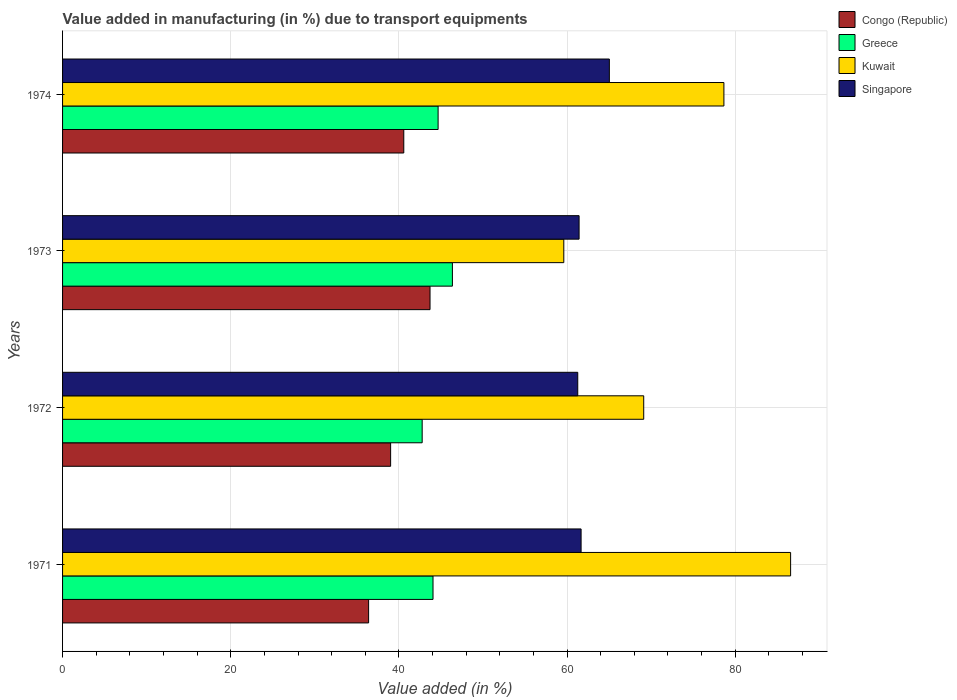How many different coloured bars are there?
Ensure brevity in your answer.  4. Are the number of bars on each tick of the Y-axis equal?
Give a very brief answer. Yes. How many bars are there on the 2nd tick from the bottom?
Keep it short and to the point. 4. What is the label of the 4th group of bars from the top?
Provide a succinct answer. 1971. In how many cases, is the number of bars for a given year not equal to the number of legend labels?
Provide a short and direct response. 0. What is the percentage of value added in manufacturing due to transport equipments in Singapore in 1971?
Your answer should be very brief. 61.67. Across all years, what is the maximum percentage of value added in manufacturing due to transport equipments in Singapore?
Offer a very short reply. 65.03. Across all years, what is the minimum percentage of value added in manufacturing due to transport equipments in Congo (Republic)?
Make the answer very short. 36.4. In which year was the percentage of value added in manufacturing due to transport equipments in Singapore maximum?
Make the answer very short. 1974. What is the total percentage of value added in manufacturing due to transport equipments in Kuwait in the graph?
Give a very brief answer. 293.97. What is the difference between the percentage of value added in manufacturing due to transport equipments in Singapore in 1971 and that in 1974?
Your answer should be very brief. -3.36. What is the difference between the percentage of value added in manufacturing due to transport equipments in Greece in 1973 and the percentage of value added in manufacturing due to transport equipments in Kuwait in 1974?
Your answer should be very brief. -32.29. What is the average percentage of value added in manufacturing due to transport equipments in Congo (Republic) per year?
Offer a terse response. 39.92. In the year 1973, what is the difference between the percentage of value added in manufacturing due to transport equipments in Greece and percentage of value added in manufacturing due to transport equipments in Congo (Republic)?
Provide a succinct answer. 2.66. What is the ratio of the percentage of value added in manufacturing due to transport equipments in Singapore in 1972 to that in 1973?
Your answer should be compact. 1. What is the difference between the highest and the second highest percentage of value added in manufacturing due to transport equipments in Singapore?
Ensure brevity in your answer.  3.36. What is the difference between the highest and the lowest percentage of value added in manufacturing due to transport equipments in Kuwait?
Provide a short and direct response. 26.97. Is the sum of the percentage of value added in manufacturing due to transport equipments in Congo (Republic) in 1973 and 1974 greater than the maximum percentage of value added in manufacturing due to transport equipments in Singapore across all years?
Ensure brevity in your answer.  Yes. What does the 3rd bar from the top in 1974 represents?
Provide a short and direct response. Greece. What does the 3rd bar from the bottom in 1973 represents?
Provide a succinct answer. Kuwait. Are all the bars in the graph horizontal?
Your answer should be compact. Yes. How many legend labels are there?
Keep it short and to the point. 4. What is the title of the graph?
Provide a short and direct response. Value added in manufacturing (in %) due to transport equipments. Does "Caribbean small states" appear as one of the legend labels in the graph?
Ensure brevity in your answer.  No. What is the label or title of the X-axis?
Ensure brevity in your answer.  Value added (in %). What is the Value added (in %) in Congo (Republic) in 1971?
Provide a short and direct response. 36.4. What is the Value added (in %) of Greece in 1971?
Ensure brevity in your answer.  44.06. What is the Value added (in %) of Kuwait in 1971?
Keep it short and to the point. 86.59. What is the Value added (in %) of Singapore in 1971?
Offer a terse response. 61.67. What is the Value added (in %) of Congo (Republic) in 1972?
Your response must be concise. 39.02. What is the Value added (in %) in Greece in 1972?
Provide a succinct answer. 42.77. What is the Value added (in %) of Kuwait in 1972?
Keep it short and to the point. 69.12. What is the Value added (in %) of Singapore in 1972?
Ensure brevity in your answer.  61.27. What is the Value added (in %) of Congo (Republic) in 1973?
Offer a very short reply. 43.7. What is the Value added (in %) in Greece in 1973?
Make the answer very short. 46.36. What is the Value added (in %) of Kuwait in 1973?
Provide a succinct answer. 59.61. What is the Value added (in %) in Singapore in 1973?
Provide a succinct answer. 61.43. What is the Value added (in %) in Congo (Republic) in 1974?
Your answer should be very brief. 40.58. What is the Value added (in %) in Greece in 1974?
Provide a short and direct response. 44.66. What is the Value added (in %) in Kuwait in 1974?
Your answer should be very brief. 78.65. What is the Value added (in %) in Singapore in 1974?
Provide a succinct answer. 65.03. Across all years, what is the maximum Value added (in %) in Congo (Republic)?
Your answer should be compact. 43.7. Across all years, what is the maximum Value added (in %) in Greece?
Make the answer very short. 46.36. Across all years, what is the maximum Value added (in %) of Kuwait?
Ensure brevity in your answer.  86.59. Across all years, what is the maximum Value added (in %) in Singapore?
Your answer should be very brief. 65.03. Across all years, what is the minimum Value added (in %) of Congo (Republic)?
Ensure brevity in your answer.  36.4. Across all years, what is the minimum Value added (in %) of Greece?
Keep it short and to the point. 42.77. Across all years, what is the minimum Value added (in %) of Kuwait?
Ensure brevity in your answer.  59.61. Across all years, what is the minimum Value added (in %) of Singapore?
Provide a short and direct response. 61.27. What is the total Value added (in %) in Congo (Republic) in the graph?
Your answer should be compact. 159.7. What is the total Value added (in %) in Greece in the graph?
Your answer should be very brief. 177.85. What is the total Value added (in %) of Kuwait in the graph?
Your answer should be very brief. 293.97. What is the total Value added (in %) in Singapore in the graph?
Give a very brief answer. 249.4. What is the difference between the Value added (in %) in Congo (Republic) in 1971 and that in 1972?
Your response must be concise. -2.62. What is the difference between the Value added (in %) of Greece in 1971 and that in 1972?
Your answer should be very brief. 1.29. What is the difference between the Value added (in %) of Kuwait in 1971 and that in 1972?
Your answer should be compact. 17.47. What is the difference between the Value added (in %) in Singapore in 1971 and that in 1972?
Make the answer very short. 0.4. What is the difference between the Value added (in %) in Congo (Republic) in 1971 and that in 1973?
Your response must be concise. -7.3. What is the difference between the Value added (in %) in Greece in 1971 and that in 1973?
Offer a terse response. -2.31. What is the difference between the Value added (in %) of Kuwait in 1971 and that in 1973?
Your answer should be compact. 26.97. What is the difference between the Value added (in %) of Singapore in 1971 and that in 1973?
Ensure brevity in your answer.  0.24. What is the difference between the Value added (in %) of Congo (Republic) in 1971 and that in 1974?
Provide a short and direct response. -4.18. What is the difference between the Value added (in %) in Greece in 1971 and that in 1974?
Offer a very short reply. -0.6. What is the difference between the Value added (in %) in Kuwait in 1971 and that in 1974?
Provide a succinct answer. 7.93. What is the difference between the Value added (in %) of Singapore in 1971 and that in 1974?
Keep it short and to the point. -3.36. What is the difference between the Value added (in %) in Congo (Republic) in 1972 and that in 1973?
Your response must be concise. -4.69. What is the difference between the Value added (in %) of Greece in 1972 and that in 1973?
Your answer should be compact. -3.6. What is the difference between the Value added (in %) of Kuwait in 1972 and that in 1973?
Give a very brief answer. 9.51. What is the difference between the Value added (in %) of Singapore in 1972 and that in 1973?
Provide a succinct answer. -0.16. What is the difference between the Value added (in %) of Congo (Republic) in 1972 and that in 1974?
Offer a very short reply. -1.57. What is the difference between the Value added (in %) in Greece in 1972 and that in 1974?
Keep it short and to the point. -1.89. What is the difference between the Value added (in %) of Kuwait in 1972 and that in 1974?
Provide a short and direct response. -9.54. What is the difference between the Value added (in %) of Singapore in 1972 and that in 1974?
Provide a short and direct response. -3.76. What is the difference between the Value added (in %) in Congo (Republic) in 1973 and that in 1974?
Offer a terse response. 3.12. What is the difference between the Value added (in %) of Greece in 1973 and that in 1974?
Provide a short and direct response. 1.7. What is the difference between the Value added (in %) in Kuwait in 1973 and that in 1974?
Your answer should be very brief. -19.04. What is the difference between the Value added (in %) of Singapore in 1973 and that in 1974?
Offer a terse response. -3.6. What is the difference between the Value added (in %) in Congo (Republic) in 1971 and the Value added (in %) in Greece in 1972?
Your answer should be very brief. -6.37. What is the difference between the Value added (in %) in Congo (Republic) in 1971 and the Value added (in %) in Kuwait in 1972?
Ensure brevity in your answer.  -32.72. What is the difference between the Value added (in %) of Congo (Republic) in 1971 and the Value added (in %) of Singapore in 1972?
Offer a very short reply. -24.87. What is the difference between the Value added (in %) of Greece in 1971 and the Value added (in %) of Kuwait in 1972?
Your answer should be compact. -25.06. What is the difference between the Value added (in %) of Greece in 1971 and the Value added (in %) of Singapore in 1972?
Your answer should be very brief. -17.21. What is the difference between the Value added (in %) of Kuwait in 1971 and the Value added (in %) of Singapore in 1972?
Your answer should be compact. 25.31. What is the difference between the Value added (in %) of Congo (Republic) in 1971 and the Value added (in %) of Greece in 1973?
Give a very brief answer. -9.97. What is the difference between the Value added (in %) of Congo (Republic) in 1971 and the Value added (in %) of Kuwait in 1973?
Offer a very short reply. -23.21. What is the difference between the Value added (in %) of Congo (Republic) in 1971 and the Value added (in %) of Singapore in 1973?
Offer a very short reply. -25.03. What is the difference between the Value added (in %) of Greece in 1971 and the Value added (in %) of Kuwait in 1973?
Keep it short and to the point. -15.55. What is the difference between the Value added (in %) in Greece in 1971 and the Value added (in %) in Singapore in 1973?
Your response must be concise. -17.37. What is the difference between the Value added (in %) in Kuwait in 1971 and the Value added (in %) in Singapore in 1973?
Keep it short and to the point. 25.16. What is the difference between the Value added (in %) in Congo (Republic) in 1971 and the Value added (in %) in Greece in 1974?
Ensure brevity in your answer.  -8.26. What is the difference between the Value added (in %) in Congo (Republic) in 1971 and the Value added (in %) in Kuwait in 1974?
Ensure brevity in your answer.  -42.26. What is the difference between the Value added (in %) in Congo (Republic) in 1971 and the Value added (in %) in Singapore in 1974?
Your answer should be very brief. -28.63. What is the difference between the Value added (in %) in Greece in 1971 and the Value added (in %) in Kuwait in 1974?
Keep it short and to the point. -34.6. What is the difference between the Value added (in %) of Greece in 1971 and the Value added (in %) of Singapore in 1974?
Your answer should be very brief. -20.97. What is the difference between the Value added (in %) of Kuwait in 1971 and the Value added (in %) of Singapore in 1974?
Offer a very short reply. 21.56. What is the difference between the Value added (in %) of Congo (Republic) in 1972 and the Value added (in %) of Greece in 1973?
Provide a short and direct response. -7.35. What is the difference between the Value added (in %) in Congo (Republic) in 1972 and the Value added (in %) in Kuwait in 1973?
Your response must be concise. -20.59. What is the difference between the Value added (in %) in Congo (Republic) in 1972 and the Value added (in %) in Singapore in 1973?
Provide a short and direct response. -22.41. What is the difference between the Value added (in %) of Greece in 1972 and the Value added (in %) of Kuwait in 1973?
Offer a terse response. -16.84. What is the difference between the Value added (in %) in Greece in 1972 and the Value added (in %) in Singapore in 1973?
Keep it short and to the point. -18.66. What is the difference between the Value added (in %) in Kuwait in 1972 and the Value added (in %) in Singapore in 1973?
Offer a very short reply. 7.69. What is the difference between the Value added (in %) in Congo (Republic) in 1972 and the Value added (in %) in Greece in 1974?
Offer a terse response. -5.65. What is the difference between the Value added (in %) in Congo (Republic) in 1972 and the Value added (in %) in Kuwait in 1974?
Your answer should be compact. -39.64. What is the difference between the Value added (in %) in Congo (Republic) in 1972 and the Value added (in %) in Singapore in 1974?
Provide a succinct answer. -26.01. What is the difference between the Value added (in %) in Greece in 1972 and the Value added (in %) in Kuwait in 1974?
Offer a very short reply. -35.89. What is the difference between the Value added (in %) in Greece in 1972 and the Value added (in %) in Singapore in 1974?
Provide a short and direct response. -22.26. What is the difference between the Value added (in %) in Kuwait in 1972 and the Value added (in %) in Singapore in 1974?
Give a very brief answer. 4.09. What is the difference between the Value added (in %) in Congo (Republic) in 1973 and the Value added (in %) in Greece in 1974?
Offer a terse response. -0.96. What is the difference between the Value added (in %) of Congo (Republic) in 1973 and the Value added (in %) of Kuwait in 1974?
Ensure brevity in your answer.  -34.95. What is the difference between the Value added (in %) of Congo (Republic) in 1973 and the Value added (in %) of Singapore in 1974?
Keep it short and to the point. -21.33. What is the difference between the Value added (in %) of Greece in 1973 and the Value added (in %) of Kuwait in 1974?
Your answer should be compact. -32.29. What is the difference between the Value added (in %) in Greece in 1973 and the Value added (in %) in Singapore in 1974?
Offer a terse response. -18.67. What is the difference between the Value added (in %) of Kuwait in 1973 and the Value added (in %) of Singapore in 1974?
Provide a succinct answer. -5.42. What is the average Value added (in %) of Congo (Republic) per year?
Give a very brief answer. 39.92. What is the average Value added (in %) of Greece per year?
Make the answer very short. 44.46. What is the average Value added (in %) of Kuwait per year?
Provide a succinct answer. 73.49. What is the average Value added (in %) of Singapore per year?
Keep it short and to the point. 62.35. In the year 1971, what is the difference between the Value added (in %) of Congo (Republic) and Value added (in %) of Greece?
Offer a terse response. -7.66. In the year 1971, what is the difference between the Value added (in %) of Congo (Republic) and Value added (in %) of Kuwait?
Provide a short and direct response. -50.19. In the year 1971, what is the difference between the Value added (in %) of Congo (Republic) and Value added (in %) of Singapore?
Offer a very short reply. -25.27. In the year 1971, what is the difference between the Value added (in %) in Greece and Value added (in %) in Kuwait?
Make the answer very short. -42.53. In the year 1971, what is the difference between the Value added (in %) of Greece and Value added (in %) of Singapore?
Give a very brief answer. -17.61. In the year 1971, what is the difference between the Value added (in %) of Kuwait and Value added (in %) of Singapore?
Keep it short and to the point. 24.92. In the year 1972, what is the difference between the Value added (in %) of Congo (Republic) and Value added (in %) of Greece?
Your response must be concise. -3.75. In the year 1972, what is the difference between the Value added (in %) of Congo (Republic) and Value added (in %) of Kuwait?
Give a very brief answer. -30.1. In the year 1972, what is the difference between the Value added (in %) of Congo (Republic) and Value added (in %) of Singapore?
Ensure brevity in your answer.  -22.25. In the year 1972, what is the difference between the Value added (in %) of Greece and Value added (in %) of Kuwait?
Provide a succinct answer. -26.35. In the year 1972, what is the difference between the Value added (in %) in Greece and Value added (in %) in Singapore?
Keep it short and to the point. -18.5. In the year 1972, what is the difference between the Value added (in %) in Kuwait and Value added (in %) in Singapore?
Provide a short and direct response. 7.85. In the year 1973, what is the difference between the Value added (in %) in Congo (Republic) and Value added (in %) in Greece?
Provide a short and direct response. -2.66. In the year 1973, what is the difference between the Value added (in %) of Congo (Republic) and Value added (in %) of Kuwait?
Make the answer very short. -15.91. In the year 1973, what is the difference between the Value added (in %) in Congo (Republic) and Value added (in %) in Singapore?
Provide a short and direct response. -17.73. In the year 1973, what is the difference between the Value added (in %) in Greece and Value added (in %) in Kuwait?
Your answer should be very brief. -13.25. In the year 1973, what is the difference between the Value added (in %) of Greece and Value added (in %) of Singapore?
Give a very brief answer. -15.07. In the year 1973, what is the difference between the Value added (in %) of Kuwait and Value added (in %) of Singapore?
Provide a short and direct response. -1.82. In the year 1974, what is the difference between the Value added (in %) of Congo (Republic) and Value added (in %) of Greece?
Offer a very short reply. -4.08. In the year 1974, what is the difference between the Value added (in %) of Congo (Republic) and Value added (in %) of Kuwait?
Ensure brevity in your answer.  -38.07. In the year 1974, what is the difference between the Value added (in %) in Congo (Republic) and Value added (in %) in Singapore?
Ensure brevity in your answer.  -24.45. In the year 1974, what is the difference between the Value added (in %) of Greece and Value added (in %) of Kuwait?
Offer a very short reply. -33.99. In the year 1974, what is the difference between the Value added (in %) of Greece and Value added (in %) of Singapore?
Make the answer very short. -20.37. In the year 1974, what is the difference between the Value added (in %) of Kuwait and Value added (in %) of Singapore?
Your answer should be very brief. 13.62. What is the ratio of the Value added (in %) of Congo (Republic) in 1971 to that in 1972?
Make the answer very short. 0.93. What is the ratio of the Value added (in %) in Greece in 1971 to that in 1972?
Make the answer very short. 1.03. What is the ratio of the Value added (in %) of Kuwait in 1971 to that in 1972?
Offer a very short reply. 1.25. What is the ratio of the Value added (in %) in Singapore in 1971 to that in 1972?
Keep it short and to the point. 1.01. What is the ratio of the Value added (in %) in Congo (Republic) in 1971 to that in 1973?
Ensure brevity in your answer.  0.83. What is the ratio of the Value added (in %) of Greece in 1971 to that in 1973?
Make the answer very short. 0.95. What is the ratio of the Value added (in %) of Kuwait in 1971 to that in 1973?
Provide a succinct answer. 1.45. What is the ratio of the Value added (in %) in Congo (Republic) in 1971 to that in 1974?
Your answer should be compact. 0.9. What is the ratio of the Value added (in %) in Greece in 1971 to that in 1974?
Give a very brief answer. 0.99. What is the ratio of the Value added (in %) in Kuwait in 1971 to that in 1974?
Provide a succinct answer. 1.1. What is the ratio of the Value added (in %) of Singapore in 1971 to that in 1974?
Provide a succinct answer. 0.95. What is the ratio of the Value added (in %) of Congo (Republic) in 1972 to that in 1973?
Your answer should be very brief. 0.89. What is the ratio of the Value added (in %) in Greece in 1972 to that in 1973?
Make the answer very short. 0.92. What is the ratio of the Value added (in %) in Kuwait in 1972 to that in 1973?
Give a very brief answer. 1.16. What is the ratio of the Value added (in %) in Singapore in 1972 to that in 1973?
Your answer should be very brief. 1. What is the ratio of the Value added (in %) of Congo (Republic) in 1972 to that in 1974?
Ensure brevity in your answer.  0.96. What is the ratio of the Value added (in %) of Greece in 1972 to that in 1974?
Your response must be concise. 0.96. What is the ratio of the Value added (in %) of Kuwait in 1972 to that in 1974?
Your response must be concise. 0.88. What is the ratio of the Value added (in %) in Singapore in 1972 to that in 1974?
Provide a succinct answer. 0.94. What is the ratio of the Value added (in %) of Congo (Republic) in 1973 to that in 1974?
Provide a short and direct response. 1.08. What is the ratio of the Value added (in %) of Greece in 1973 to that in 1974?
Make the answer very short. 1.04. What is the ratio of the Value added (in %) of Kuwait in 1973 to that in 1974?
Make the answer very short. 0.76. What is the ratio of the Value added (in %) of Singapore in 1973 to that in 1974?
Ensure brevity in your answer.  0.94. What is the difference between the highest and the second highest Value added (in %) of Congo (Republic)?
Give a very brief answer. 3.12. What is the difference between the highest and the second highest Value added (in %) of Greece?
Make the answer very short. 1.7. What is the difference between the highest and the second highest Value added (in %) of Kuwait?
Your response must be concise. 7.93. What is the difference between the highest and the second highest Value added (in %) in Singapore?
Ensure brevity in your answer.  3.36. What is the difference between the highest and the lowest Value added (in %) of Congo (Republic)?
Provide a short and direct response. 7.3. What is the difference between the highest and the lowest Value added (in %) of Greece?
Make the answer very short. 3.6. What is the difference between the highest and the lowest Value added (in %) in Kuwait?
Offer a terse response. 26.97. What is the difference between the highest and the lowest Value added (in %) in Singapore?
Keep it short and to the point. 3.76. 